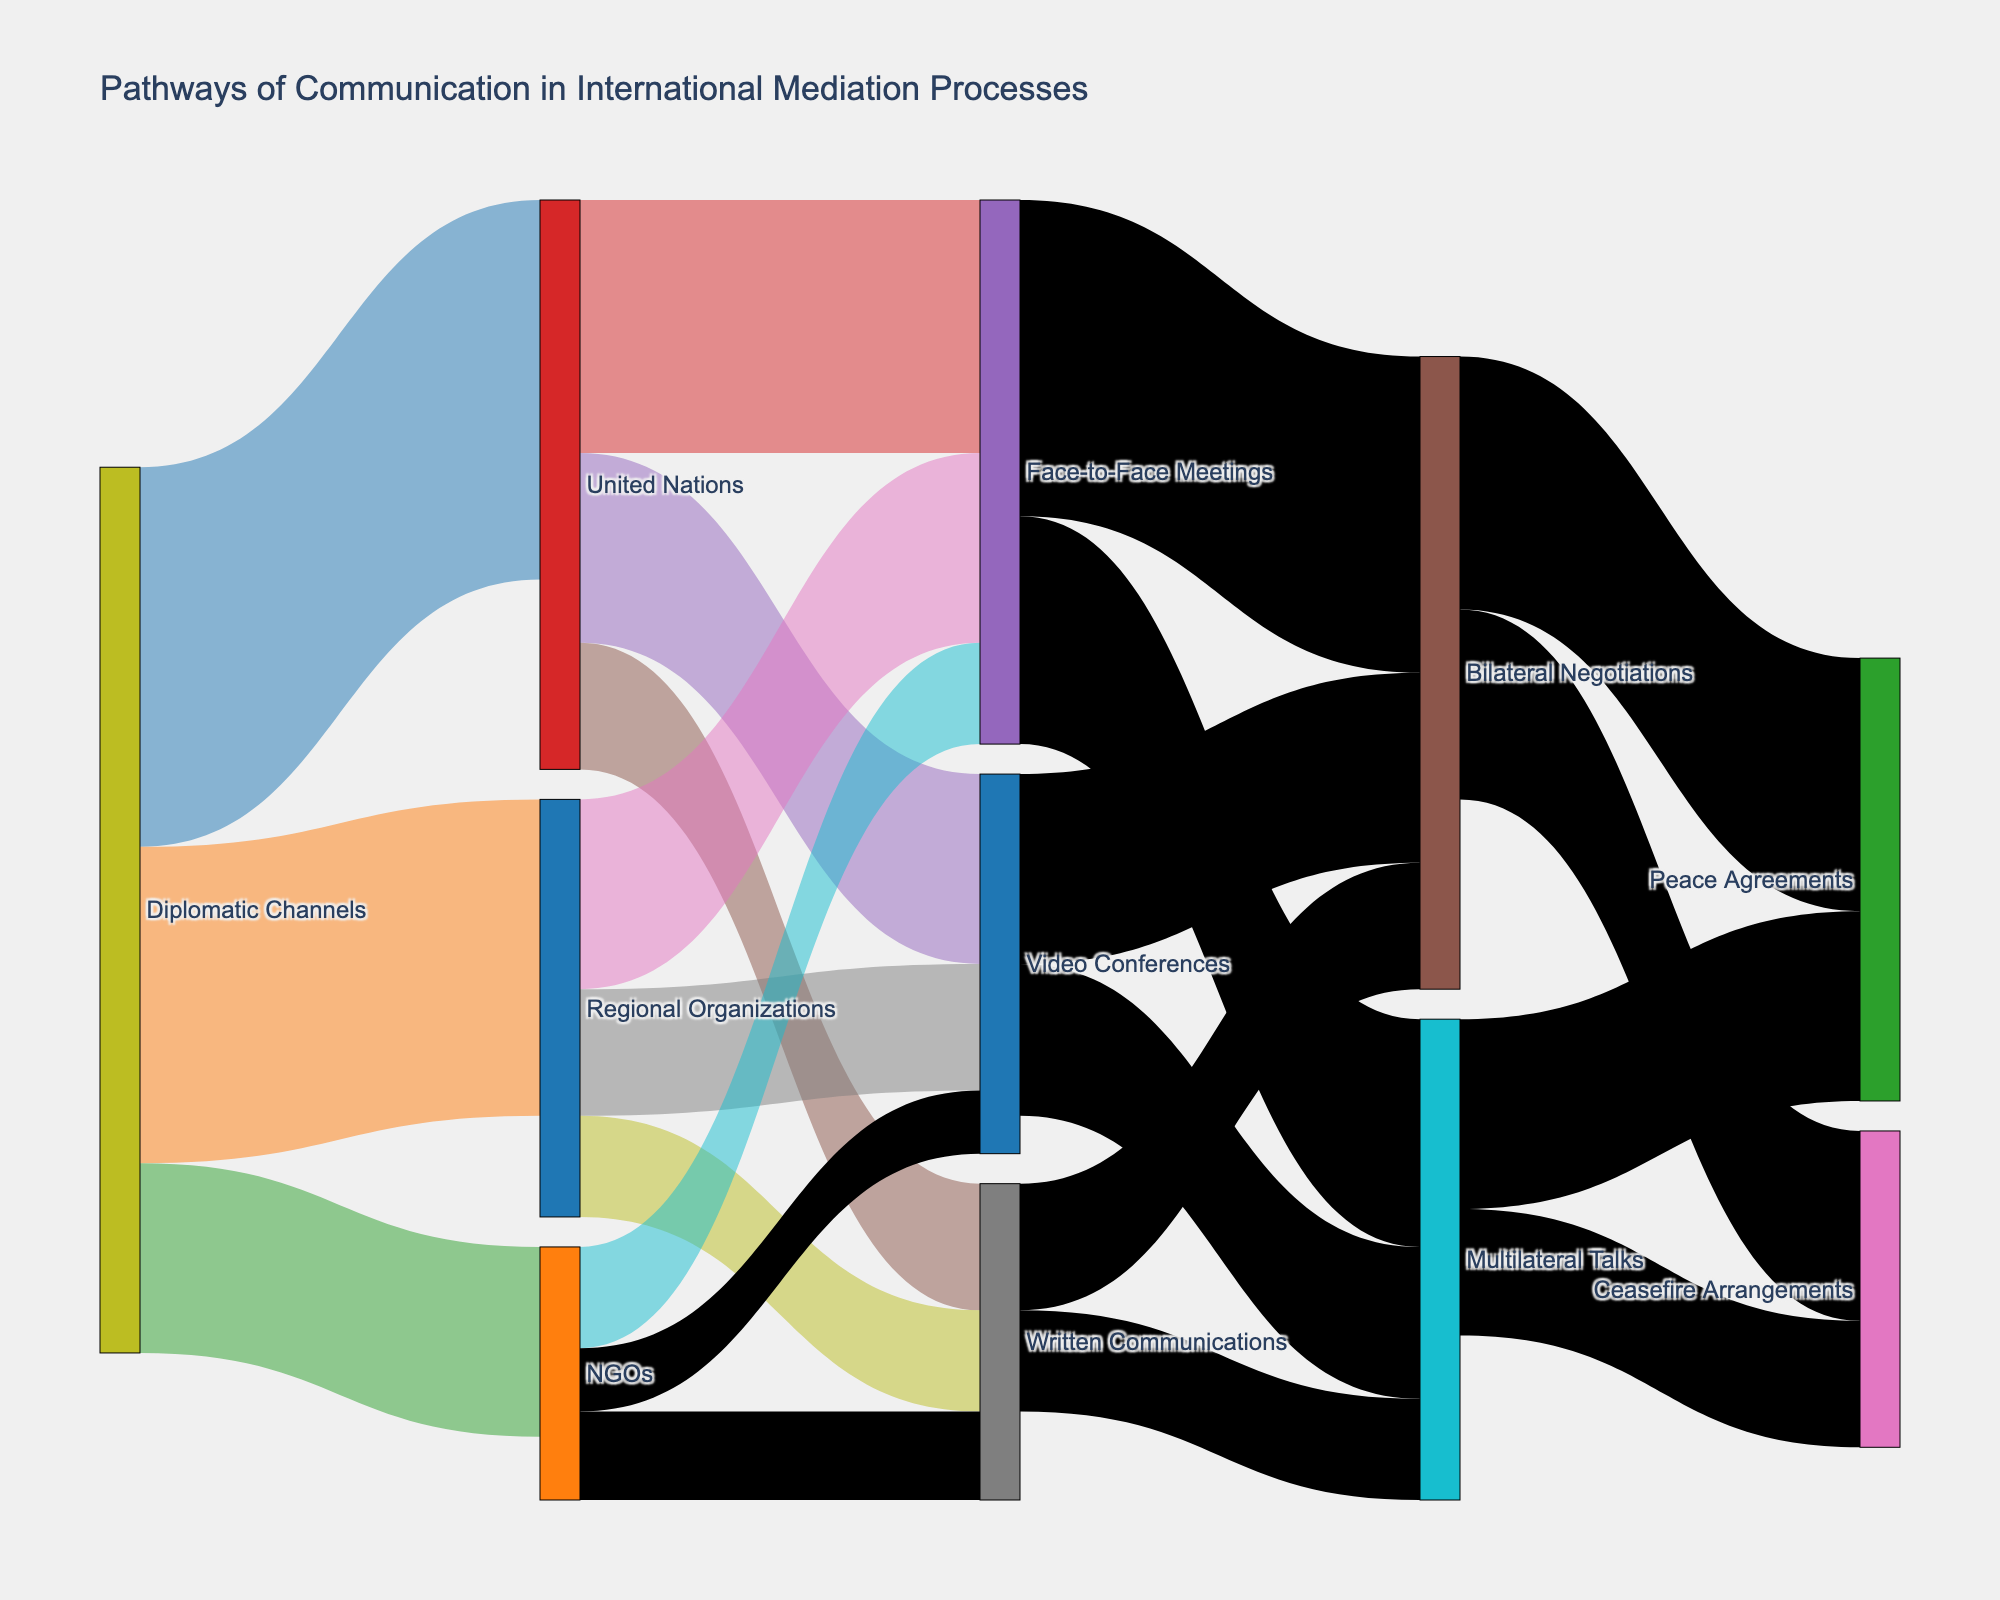What's the title of the Sankey Diagram? The title is displayed at the top of the figure, indicating the main subject being visualized. The title of the Sankey Diagram is "Pathways of Communication in International Mediation Processes".
Answer: Pathways of Communication in International Mediation Processes How many total channels flow out of Diplomatic Channels? Look at the 'Diplomatic Channels' node and count all links flowing out of it. There are three links: one to United Nations (30), one to Regional Organizations (25), and one to NGOs (15).
Answer: 3 Which pathway has the highest individual value and what is that value? Check each link's value and identify the highest one. The link from 'Diplomatic Channels' to 'United Nations' has the highest value, which is 30.
Answer: Diplomatic Channels to United Nations, 30 What is the sum of all values flowing into 'Bilateral Negotiations'? Identify all links flowing into 'Bilateral Negotiations' and sum their values. The links are from 'Face-to-Face Meetings' (25), 'Video Conferences' (15), and 'Written Communications' (10). Adding these gives 25 + 15 + 10 = 50.
Answer: 50 Which method received the most communication from NGOs? Examine the links originating from NGOs, and find which target node has the highest value. 'NGOs' sends 8 to 'Face-to-Face Meetings', 5 to 'Video Conferences', and 7 to 'Written Communications'. The maximum value is 8 to 'Face-to-Face Meetings'.
Answer: Face-to-Face Meetings What is the total value flowing from 'Face-to-Face Meetings' to any other node? Identify all outgoing links from 'Face-to-Face Meetings' and add their values. The links are 25 to 'Bilateral Negotiations' and 18 to 'Multilateral Talks'. Summing them gives 25 + 18 = 43.
Answer: 43 Compare the total values of communications handled by United Nations and Regional Organizations. Which one handles more, and by how much? Sum the values of all links coming into United Nations and do the same for Regional Organizations. United Nations receives 30, 20, 15, and 10 totaling 75. Regional Organizations receive 25, 15, 10, and 8 totaling 58. United Nations handles 75 - 58 = 17 more.
Answer: United Nations by 17 What percentage of the total communication via Video Conferences ends up as Ceasefire Arrangements? Identify all pathways involving Video Conferences and sum their values: 15 and 12. Then, find the value flowing through Video Conferences to Ceasefire Arrangements, which is 10. The percentage is (10 / (15+12)) * 100 = 27.03%.
Answer: 27.03% Among Peace Agreements and Ceasefire Arrangements, which has a higher total incoming value, and what is the difference between the two? Find all values flowing into Peace Agreements and Ceasefire Arrangements. Peace Agreements receive 20 from Bilateral Negotiations and 15 from Multilateral Talks, totaling 35. Ceasefire Arrangements receive 15 from Bilateral Negotiations and 10 from Multilateral Talks, totaling 25. The difference is 35 - 25 = 10.
Answer: Peace Agreements by 10 